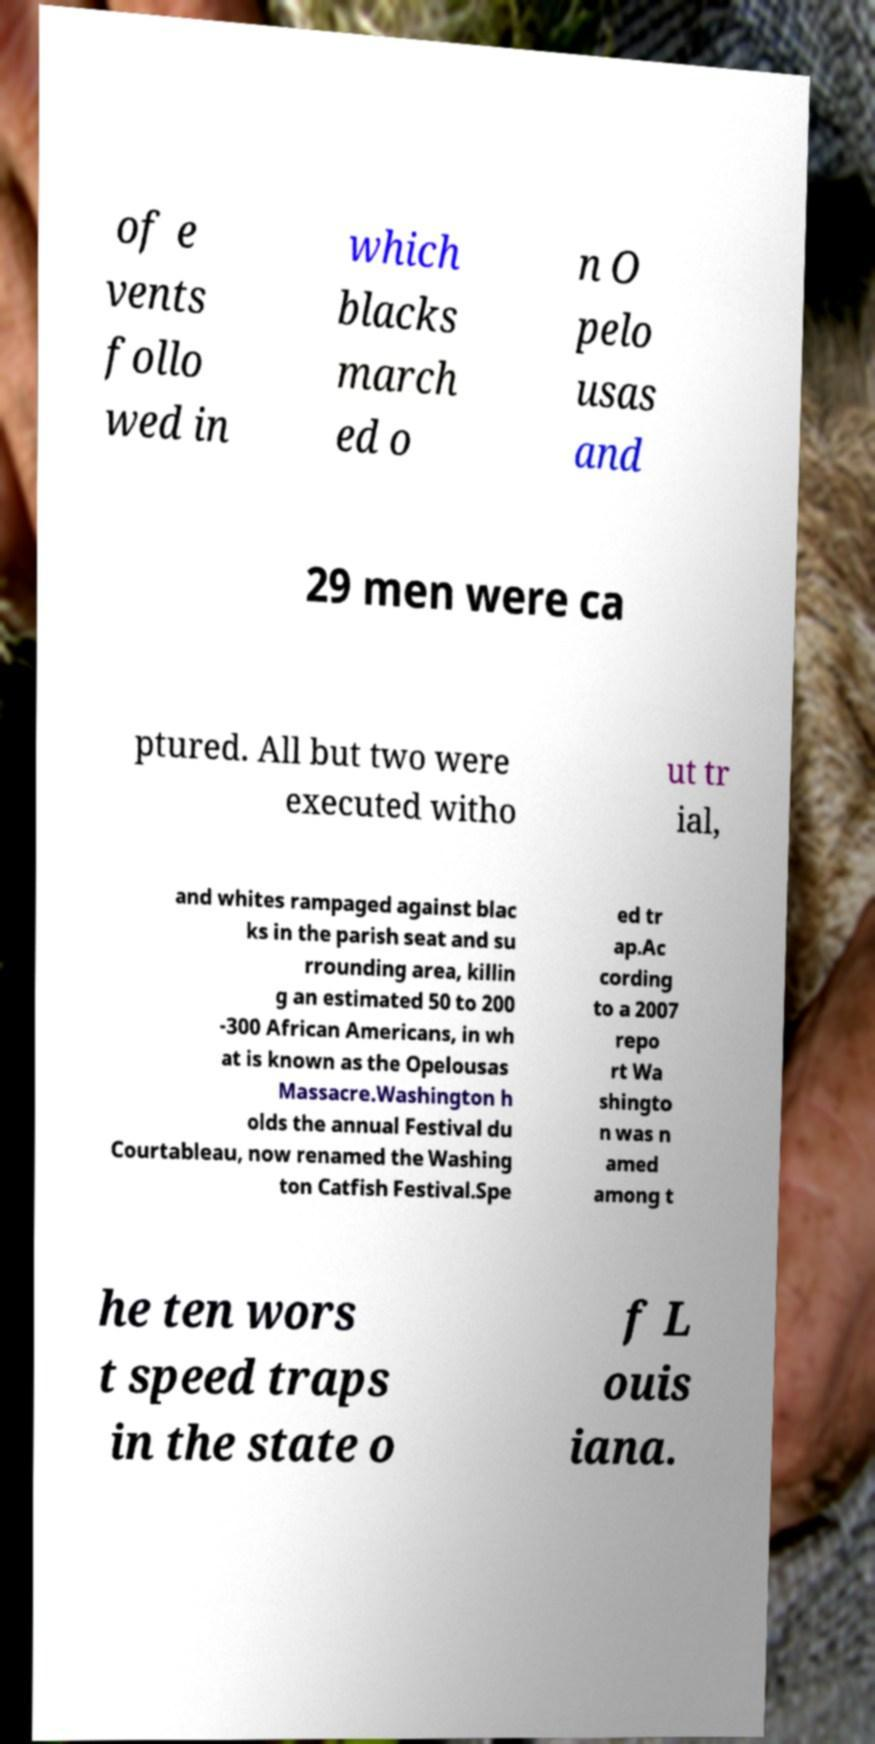Could you extract and type out the text from this image? of e vents follo wed in which blacks march ed o n O pelo usas and 29 men were ca ptured. All but two were executed witho ut tr ial, and whites rampaged against blac ks in the parish seat and su rrounding area, killin g an estimated 50 to 200 -300 African Americans, in wh at is known as the Opelousas Massacre.Washington h olds the annual Festival du Courtableau, now renamed the Washing ton Catfish Festival.Spe ed tr ap.Ac cording to a 2007 repo rt Wa shingto n was n amed among t he ten wors t speed traps in the state o f L ouis iana. 